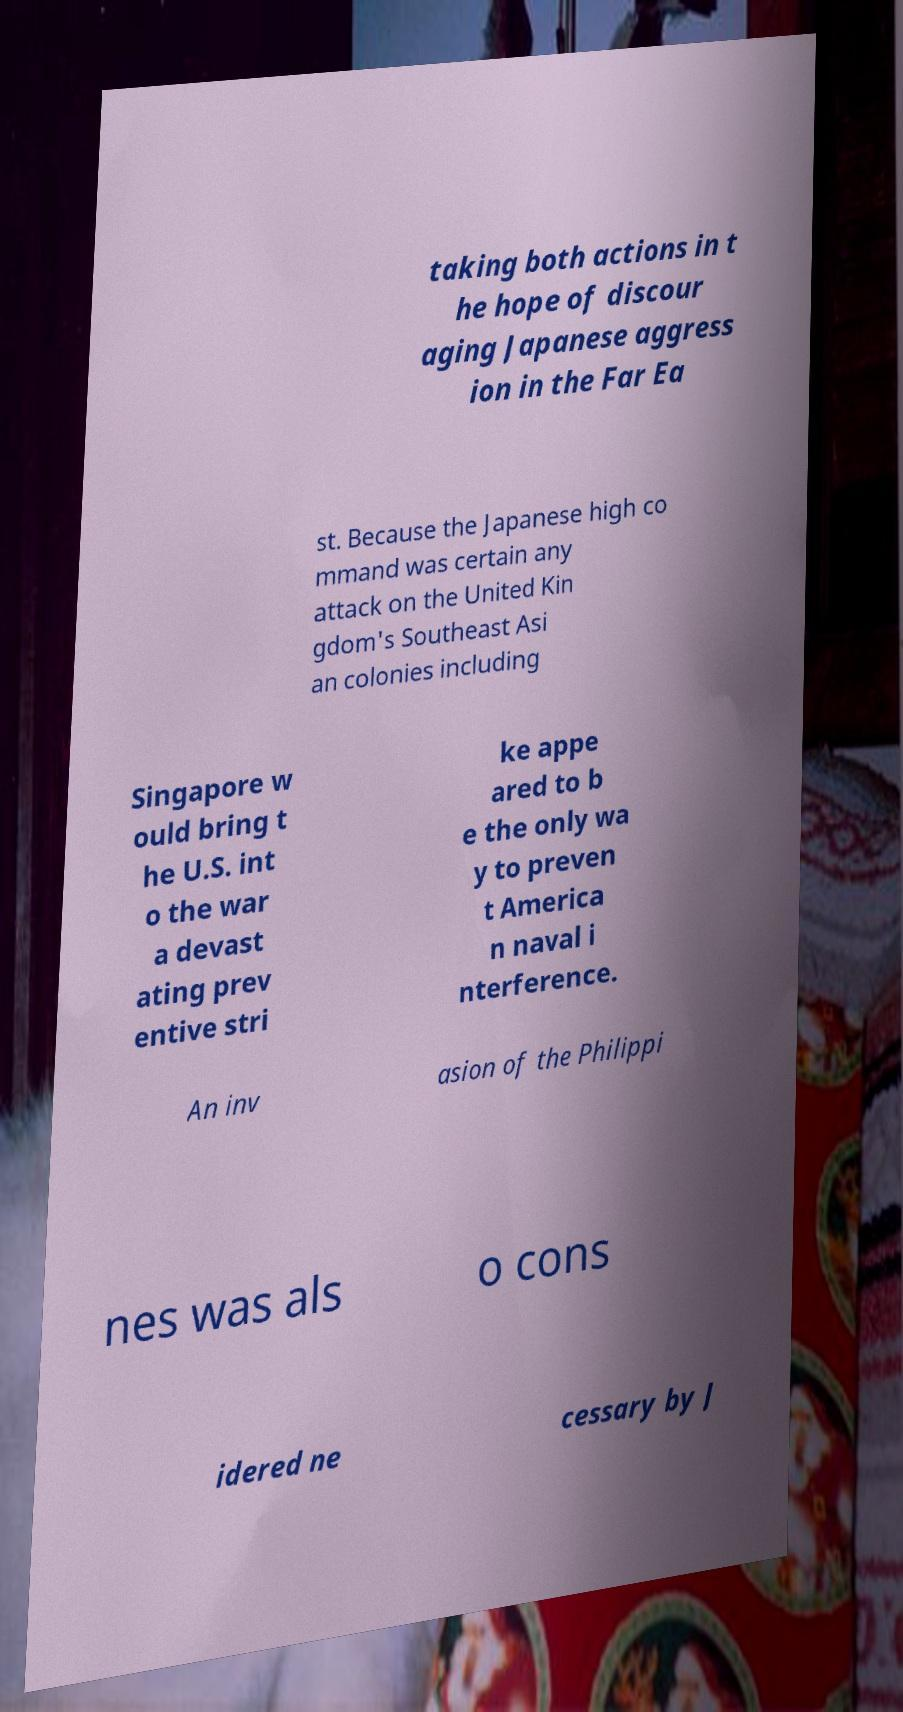Can you accurately transcribe the text from the provided image for me? taking both actions in t he hope of discour aging Japanese aggress ion in the Far Ea st. Because the Japanese high co mmand was certain any attack on the United Kin gdom's Southeast Asi an colonies including Singapore w ould bring t he U.S. int o the war a devast ating prev entive stri ke appe ared to b e the only wa y to preven t America n naval i nterference. An inv asion of the Philippi nes was als o cons idered ne cessary by J 